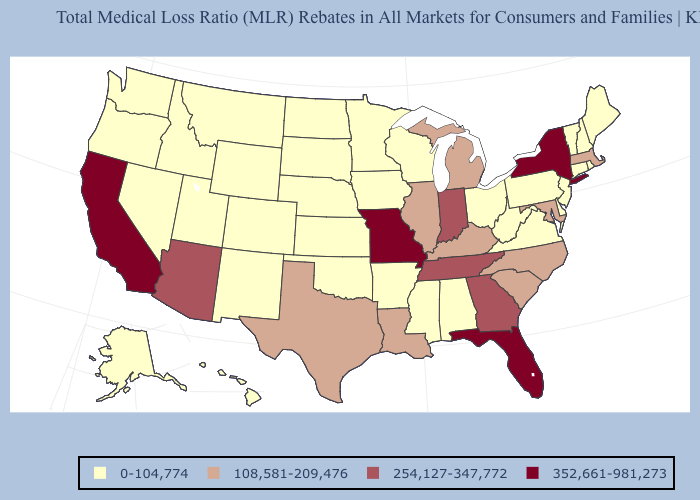Does Maryland have a higher value than New York?
Be succinct. No. What is the highest value in the USA?
Concise answer only. 352,661-981,273. Among the states that border Pennsylvania , which have the highest value?
Answer briefly. New York. Does Florida have a lower value than South Carolina?
Short answer required. No. Which states have the highest value in the USA?
Short answer required. California, Florida, Missouri, New York. What is the value of Indiana?
Keep it brief. 254,127-347,772. Name the states that have a value in the range 108,581-209,476?
Be succinct. Illinois, Kentucky, Louisiana, Maryland, Massachusetts, Michigan, North Carolina, South Carolina, Texas. What is the highest value in the USA?
Quick response, please. 352,661-981,273. What is the value of Nevada?
Answer briefly. 0-104,774. How many symbols are there in the legend?
Quick response, please. 4. Does Massachusetts have the highest value in the Northeast?
Concise answer only. No. Does Wyoming have the same value as North Carolina?
Keep it brief. No. Which states have the lowest value in the West?
Write a very short answer. Alaska, Colorado, Hawaii, Idaho, Montana, Nevada, New Mexico, Oregon, Utah, Washington, Wyoming. Which states have the highest value in the USA?
Keep it brief. California, Florida, Missouri, New York. What is the value of North Dakota?
Concise answer only. 0-104,774. 